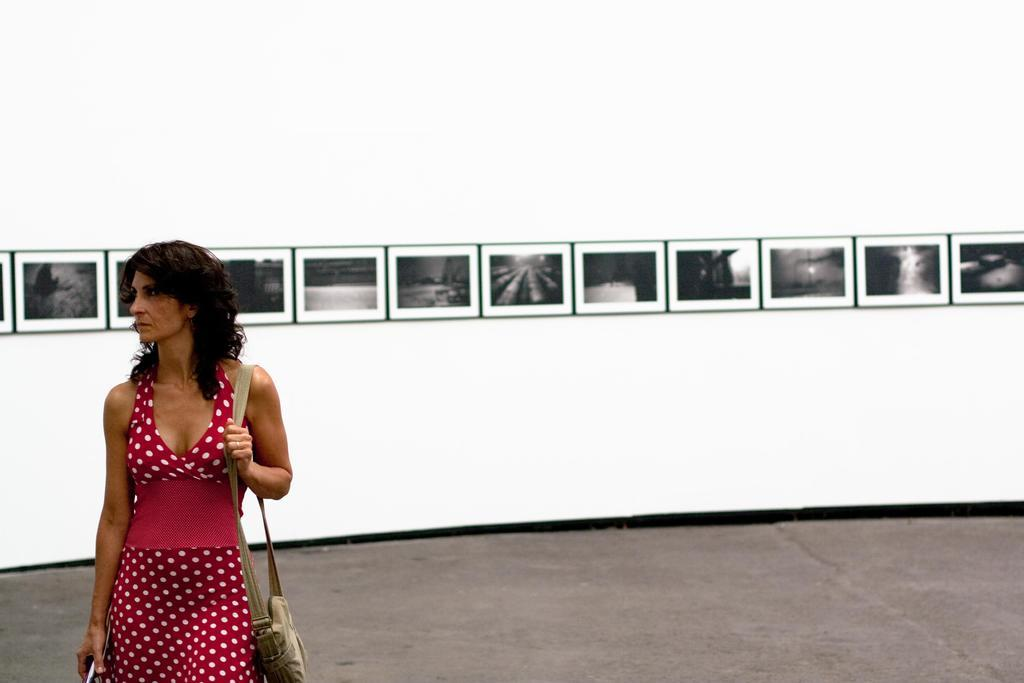Who is the main subject in the image? There is a woman in the image. What is the woman wearing? The woman is wearing a red dress. What is the woman carrying? The woman is carrying a bag. What is the woman doing in the image? The woman is walking on the ground. What can be seen on the wall in the background? There are photo frames on a white color wall in the background. Are there any dogs playing in the sleet in the image? There are no dogs or sleet present in the image. 